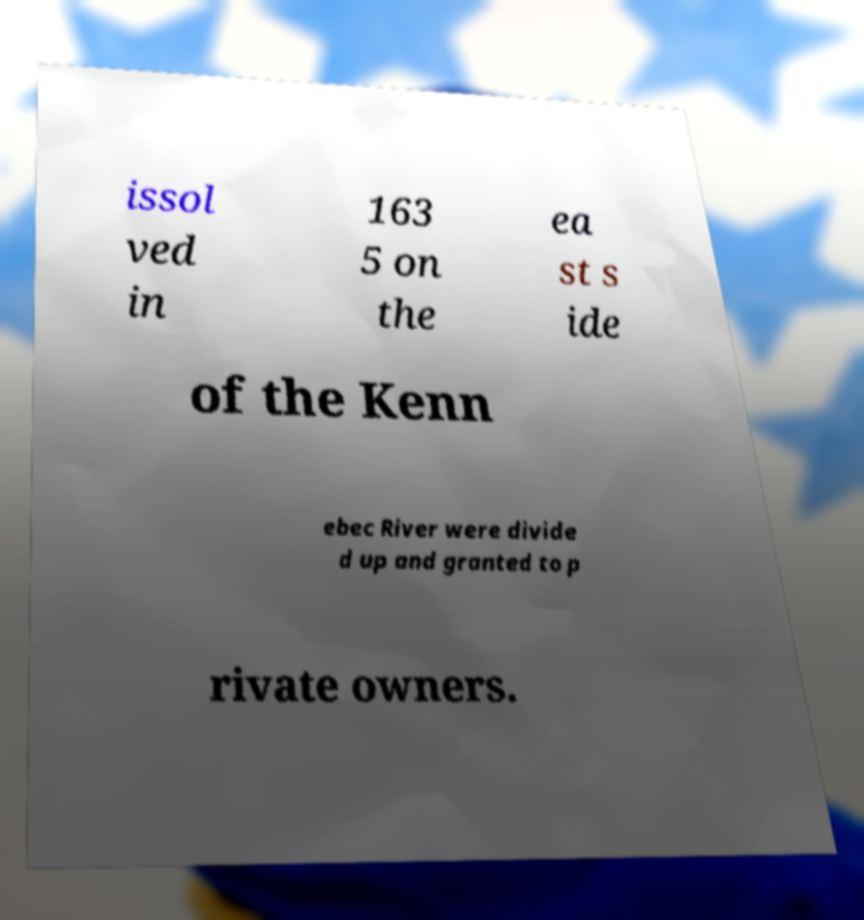There's text embedded in this image that I need extracted. Can you transcribe it verbatim? issol ved in 163 5 on the ea st s ide of the Kenn ebec River were divide d up and granted to p rivate owners. 